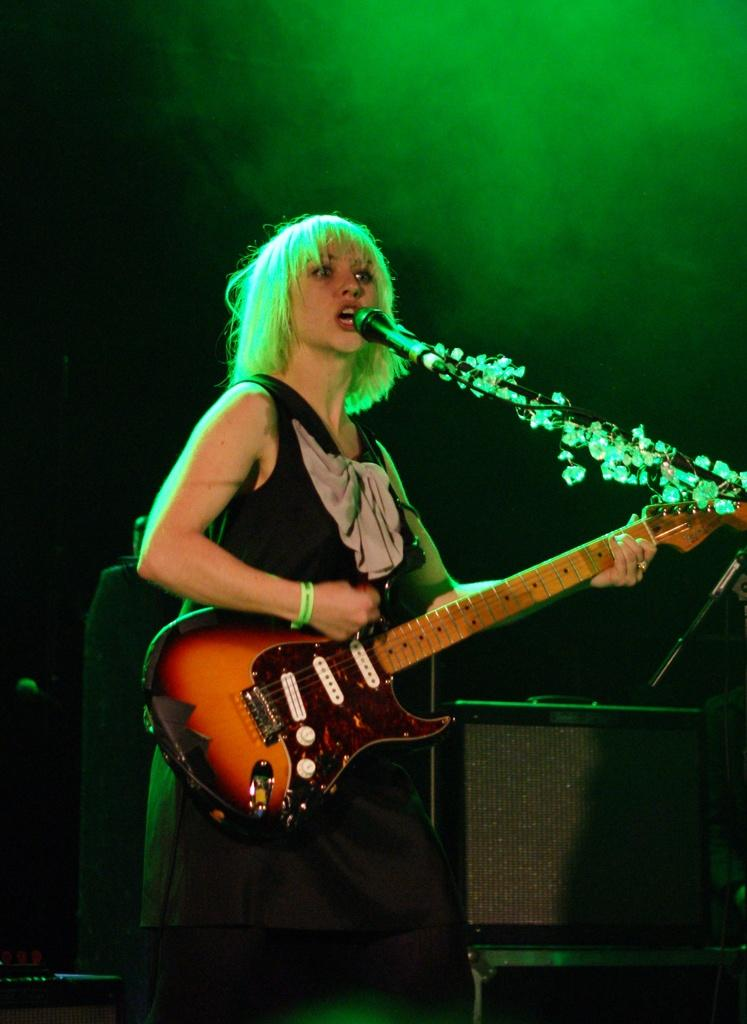What is the person in the image holding? The person is holding a musical instrument. What device is present for amplifying sound? There is a microphone in the image. Can you describe any other objects in the image? There are some unspecified objects in the image. How many plants are visible in the image? There are no plants visible in the image. What type of comfort can be seen being provided by the person in the image? The image does not show any comfort being provided by the person; they are holding a musical instrument and standing near a microphone. 